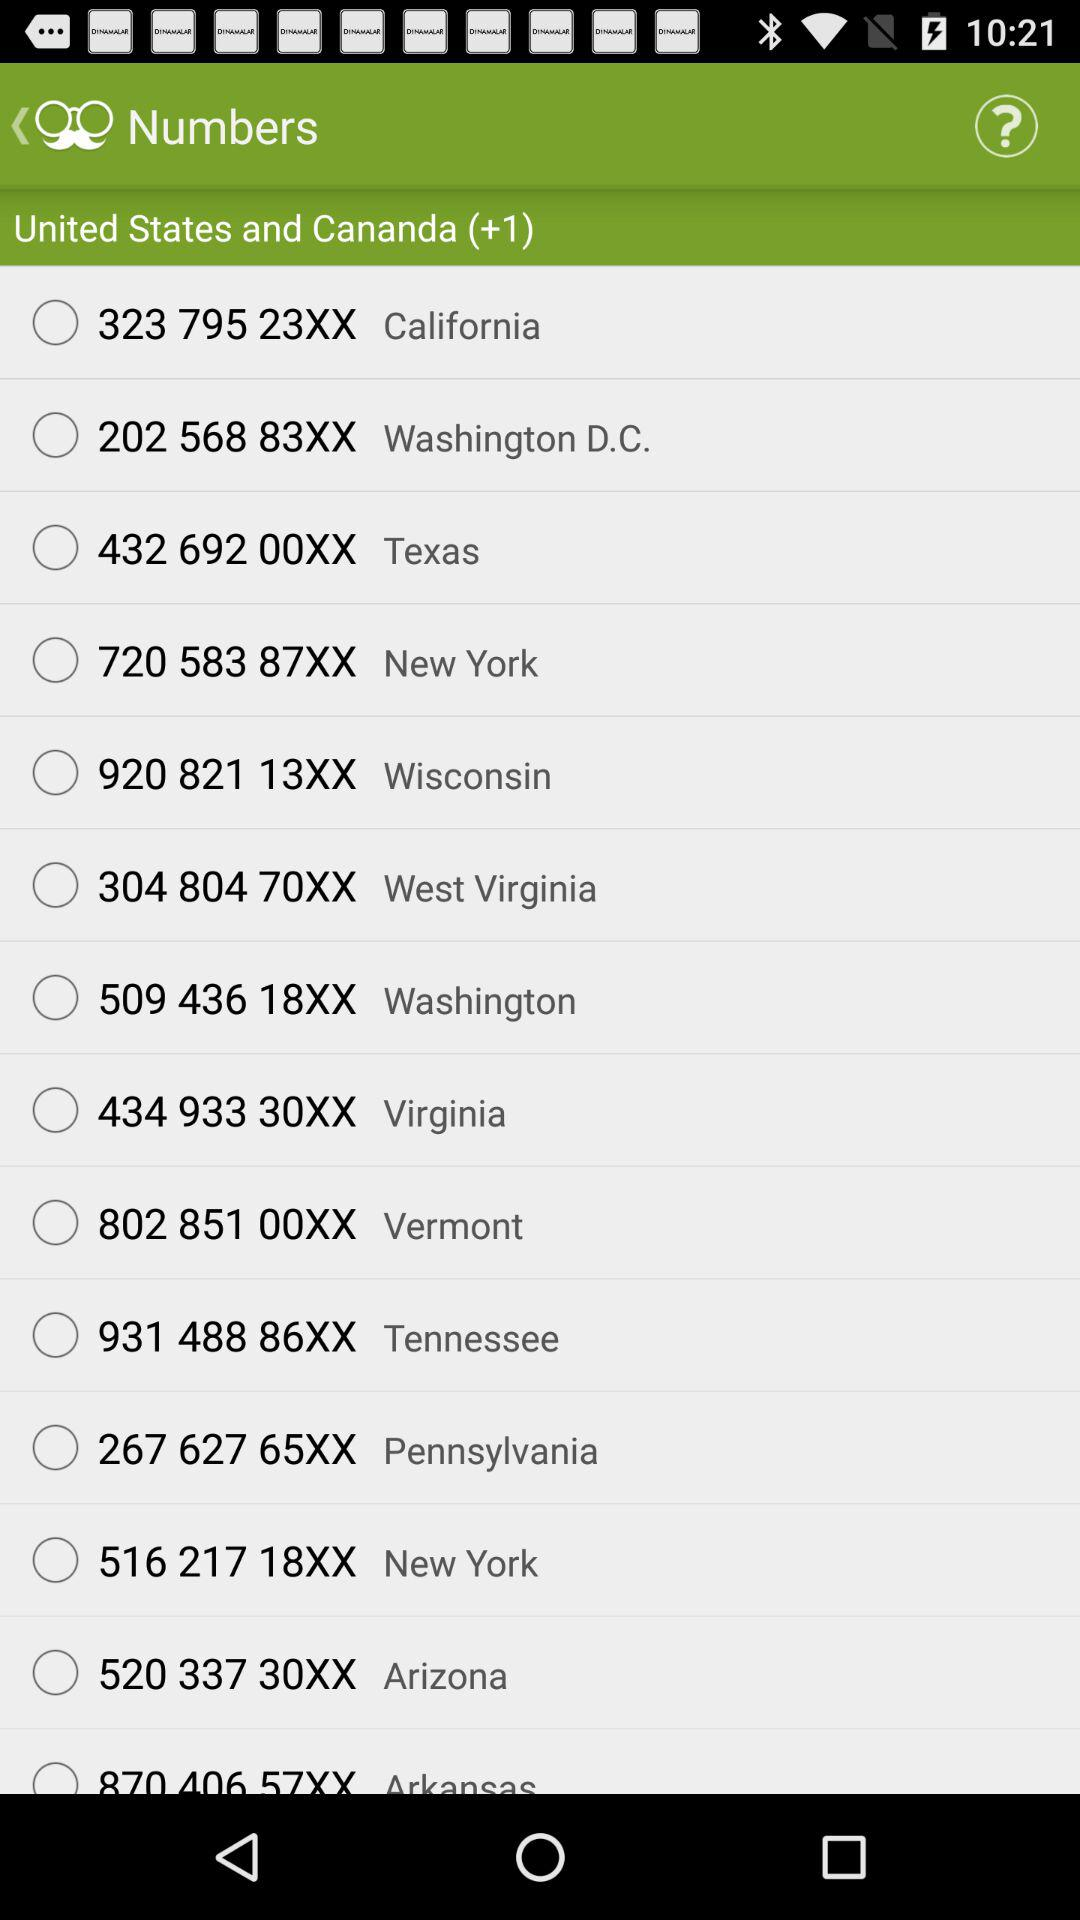What is the country code for the USA and Canada? The country code for the USA and Canada is +1. 